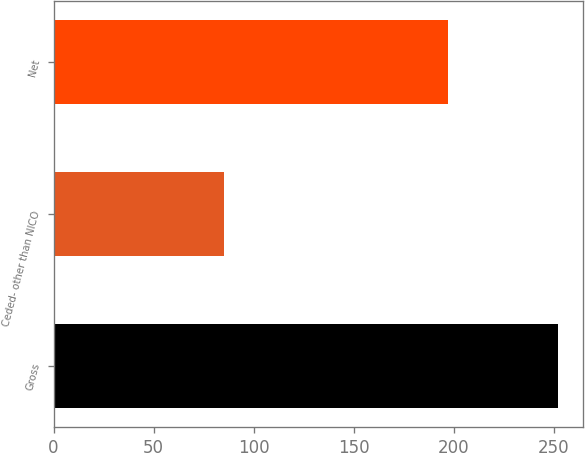Convert chart. <chart><loc_0><loc_0><loc_500><loc_500><bar_chart><fcel>Gross<fcel>Ceded- other than NICO<fcel>Net<nl><fcel>252<fcel>85<fcel>197<nl></chart> 